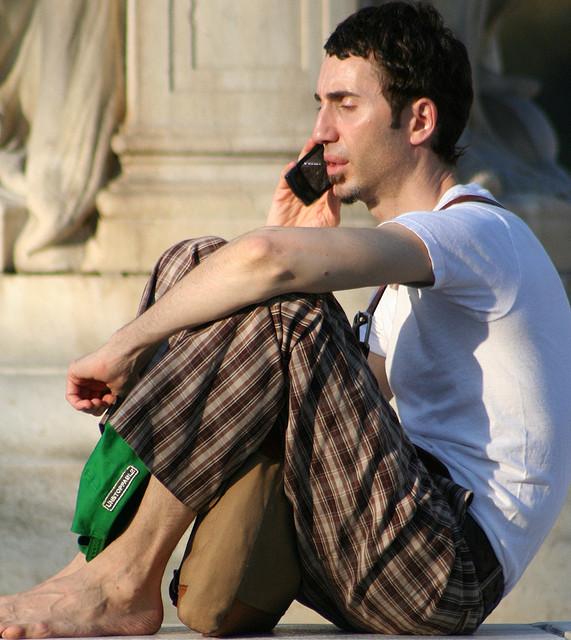Is this man wearing shoes?
Concise answer only. No. Is the man on the phone?
Write a very short answer. Yes. Is the man sitting on a chair?
Quick response, please. No. What shape is the medallion is the end of the man's necklace?
Concise answer only. Circle. How many people are in the photo?
Answer briefly. 1. 